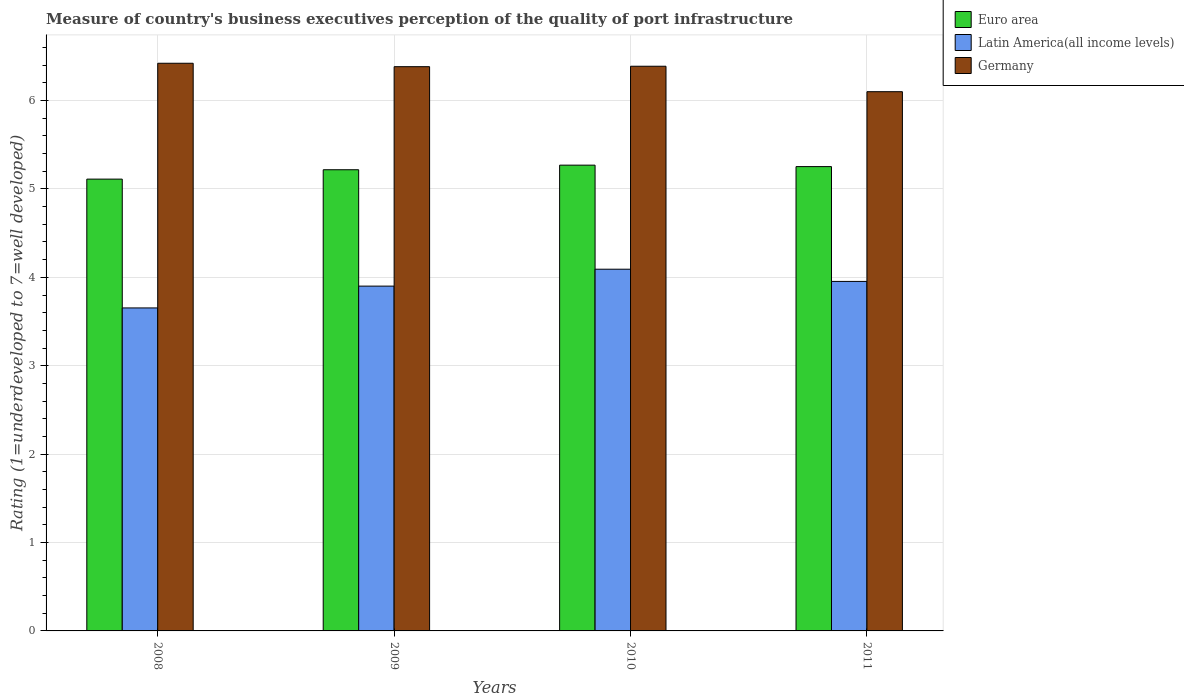How many groups of bars are there?
Offer a very short reply. 4. Are the number of bars per tick equal to the number of legend labels?
Make the answer very short. Yes. How many bars are there on the 2nd tick from the left?
Keep it short and to the point. 3. How many bars are there on the 3rd tick from the right?
Offer a terse response. 3. What is the label of the 1st group of bars from the left?
Your response must be concise. 2008. In how many cases, is the number of bars for a given year not equal to the number of legend labels?
Provide a succinct answer. 0. What is the ratings of the quality of port infrastructure in Euro area in 2009?
Offer a terse response. 5.22. Across all years, what is the maximum ratings of the quality of port infrastructure in Germany?
Offer a terse response. 6.42. In which year was the ratings of the quality of port infrastructure in Germany minimum?
Give a very brief answer. 2011. What is the total ratings of the quality of port infrastructure in Latin America(all income levels) in the graph?
Keep it short and to the point. 15.6. What is the difference between the ratings of the quality of port infrastructure in Germany in 2009 and that in 2011?
Keep it short and to the point. 0.28. What is the difference between the ratings of the quality of port infrastructure in Euro area in 2010 and the ratings of the quality of port infrastructure in Germany in 2009?
Give a very brief answer. -1.11. What is the average ratings of the quality of port infrastructure in Euro area per year?
Ensure brevity in your answer.  5.21. In the year 2011, what is the difference between the ratings of the quality of port infrastructure in Latin America(all income levels) and ratings of the quality of port infrastructure in Germany?
Your answer should be very brief. -2.15. What is the ratio of the ratings of the quality of port infrastructure in Germany in 2009 to that in 2011?
Keep it short and to the point. 1.05. Is the ratings of the quality of port infrastructure in Euro area in 2009 less than that in 2010?
Your answer should be very brief. Yes. Is the difference between the ratings of the quality of port infrastructure in Latin America(all income levels) in 2008 and 2011 greater than the difference between the ratings of the quality of port infrastructure in Germany in 2008 and 2011?
Provide a succinct answer. No. What is the difference between the highest and the second highest ratings of the quality of port infrastructure in Latin America(all income levels)?
Your answer should be very brief. 0.14. What is the difference between the highest and the lowest ratings of the quality of port infrastructure in Euro area?
Offer a terse response. 0.16. Is the sum of the ratings of the quality of port infrastructure in Euro area in 2009 and 2010 greater than the maximum ratings of the quality of port infrastructure in Latin America(all income levels) across all years?
Your answer should be compact. Yes. What does the 1st bar from the right in 2008 represents?
Ensure brevity in your answer.  Germany. Are all the bars in the graph horizontal?
Keep it short and to the point. No. What is the difference between two consecutive major ticks on the Y-axis?
Your answer should be compact. 1. Does the graph contain grids?
Keep it short and to the point. Yes. Where does the legend appear in the graph?
Offer a terse response. Top right. How many legend labels are there?
Ensure brevity in your answer.  3. What is the title of the graph?
Offer a very short reply. Measure of country's business executives perception of the quality of port infrastructure. Does "Indonesia" appear as one of the legend labels in the graph?
Provide a short and direct response. No. What is the label or title of the Y-axis?
Offer a very short reply. Rating (1=underdeveloped to 7=well developed). What is the Rating (1=underdeveloped to 7=well developed) of Euro area in 2008?
Give a very brief answer. 5.11. What is the Rating (1=underdeveloped to 7=well developed) in Latin America(all income levels) in 2008?
Provide a short and direct response. 3.65. What is the Rating (1=underdeveloped to 7=well developed) in Germany in 2008?
Offer a terse response. 6.42. What is the Rating (1=underdeveloped to 7=well developed) in Euro area in 2009?
Your answer should be very brief. 5.22. What is the Rating (1=underdeveloped to 7=well developed) in Latin America(all income levels) in 2009?
Make the answer very short. 3.9. What is the Rating (1=underdeveloped to 7=well developed) of Germany in 2009?
Your answer should be compact. 6.38. What is the Rating (1=underdeveloped to 7=well developed) in Euro area in 2010?
Make the answer very short. 5.27. What is the Rating (1=underdeveloped to 7=well developed) in Latin America(all income levels) in 2010?
Your answer should be very brief. 4.09. What is the Rating (1=underdeveloped to 7=well developed) in Germany in 2010?
Offer a very short reply. 6.39. What is the Rating (1=underdeveloped to 7=well developed) in Euro area in 2011?
Your answer should be very brief. 5.25. What is the Rating (1=underdeveloped to 7=well developed) in Latin America(all income levels) in 2011?
Make the answer very short. 3.95. What is the Rating (1=underdeveloped to 7=well developed) of Germany in 2011?
Give a very brief answer. 6.1. Across all years, what is the maximum Rating (1=underdeveloped to 7=well developed) of Euro area?
Keep it short and to the point. 5.27. Across all years, what is the maximum Rating (1=underdeveloped to 7=well developed) of Latin America(all income levels)?
Provide a succinct answer. 4.09. Across all years, what is the maximum Rating (1=underdeveloped to 7=well developed) of Germany?
Your answer should be very brief. 6.42. Across all years, what is the minimum Rating (1=underdeveloped to 7=well developed) of Euro area?
Provide a succinct answer. 5.11. Across all years, what is the minimum Rating (1=underdeveloped to 7=well developed) in Latin America(all income levels)?
Your response must be concise. 3.65. What is the total Rating (1=underdeveloped to 7=well developed) in Euro area in the graph?
Your response must be concise. 20.85. What is the total Rating (1=underdeveloped to 7=well developed) of Latin America(all income levels) in the graph?
Offer a very short reply. 15.6. What is the total Rating (1=underdeveloped to 7=well developed) of Germany in the graph?
Keep it short and to the point. 25.29. What is the difference between the Rating (1=underdeveloped to 7=well developed) in Euro area in 2008 and that in 2009?
Provide a short and direct response. -0.11. What is the difference between the Rating (1=underdeveloped to 7=well developed) in Latin America(all income levels) in 2008 and that in 2009?
Offer a terse response. -0.25. What is the difference between the Rating (1=underdeveloped to 7=well developed) of Germany in 2008 and that in 2009?
Offer a terse response. 0.04. What is the difference between the Rating (1=underdeveloped to 7=well developed) of Euro area in 2008 and that in 2010?
Provide a short and direct response. -0.16. What is the difference between the Rating (1=underdeveloped to 7=well developed) of Latin America(all income levels) in 2008 and that in 2010?
Offer a very short reply. -0.44. What is the difference between the Rating (1=underdeveloped to 7=well developed) of Germany in 2008 and that in 2010?
Keep it short and to the point. 0.03. What is the difference between the Rating (1=underdeveloped to 7=well developed) in Euro area in 2008 and that in 2011?
Provide a short and direct response. -0.14. What is the difference between the Rating (1=underdeveloped to 7=well developed) of Germany in 2008 and that in 2011?
Provide a succinct answer. 0.32. What is the difference between the Rating (1=underdeveloped to 7=well developed) of Euro area in 2009 and that in 2010?
Your answer should be compact. -0.05. What is the difference between the Rating (1=underdeveloped to 7=well developed) in Latin America(all income levels) in 2009 and that in 2010?
Offer a very short reply. -0.19. What is the difference between the Rating (1=underdeveloped to 7=well developed) in Germany in 2009 and that in 2010?
Give a very brief answer. -0. What is the difference between the Rating (1=underdeveloped to 7=well developed) of Euro area in 2009 and that in 2011?
Keep it short and to the point. -0.04. What is the difference between the Rating (1=underdeveloped to 7=well developed) in Latin America(all income levels) in 2009 and that in 2011?
Offer a terse response. -0.05. What is the difference between the Rating (1=underdeveloped to 7=well developed) of Germany in 2009 and that in 2011?
Offer a terse response. 0.28. What is the difference between the Rating (1=underdeveloped to 7=well developed) in Euro area in 2010 and that in 2011?
Your response must be concise. 0.02. What is the difference between the Rating (1=underdeveloped to 7=well developed) of Latin America(all income levels) in 2010 and that in 2011?
Offer a very short reply. 0.14. What is the difference between the Rating (1=underdeveloped to 7=well developed) of Germany in 2010 and that in 2011?
Your answer should be very brief. 0.29. What is the difference between the Rating (1=underdeveloped to 7=well developed) of Euro area in 2008 and the Rating (1=underdeveloped to 7=well developed) of Latin America(all income levels) in 2009?
Make the answer very short. 1.21. What is the difference between the Rating (1=underdeveloped to 7=well developed) of Euro area in 2008 and the Rating (1=underdeveloped to 7=well developed) of Germany in 2009?
Ensure brevity in your answer.  -1.27. What is the difference between the Rating (1=underdeveloped to 7=well developed) in Latin America(all income levels) in 2008 and the Rating (1=underdeveloped to 7=well developed) in Germany in 2009?
Give a very brief answer. -2.73. What is the difference between the Rating (1=underdeveloped to 7=well developed) in Euro area in 2008 and the Rating (1=underdeveloped to 7=well developed) in Latin America(all income levels) in 2010?
Ensure brevity in your answer.  1.02. What is the difference between the Rating (1=underdeveloped to 7=well developed) in Euro area in 2008 and the Rating (1=underdeveloped to 7=well developed) in Germany in 2010?
Keep it short and to the point. -1.28. What is the difference between the Rating (1=underdeveloped to 7=well developed) in Latin America(all income levels) in 2008 and the Rating (1=underdeveloped to 7=well developed) in Germany in 2010?
Your response must be concise. -2.73. What is the difference between the Rating (1=underdeveloped to 7=well developed) of Euro area in 2008 and the Rating (1=underdeveloped to 7=well developed) of Latin America(all income levels) in 2011?
Give a very brief answer. 1.16. What is the difference between the Rating (1=underdeveloped to 7=well developed) of Euro area in 2008 and the Rating (1=underdeveloped to 7=well developed) of Germany in 2011?
Provide a short and direct response. -0.99. What is the difference between the Rating (1=underdeveloped to 7=well developed) in Latin America(all income levels) in 2008 and the Rating (1=underdeveloped to 7=well developed) in Germany in 2011?
Your answer should be compact. -2.45. What is the difference between the Rating (1=underdeveloped to 7=well developed) of Euro area in 2009 and the Rating (1=underdeveloped to 7=well developed) of Latin America(all income levels) in 2010?
Your answer should be very brief. 1.13. What is the difference between the Rating (1=underdeveloped to 7=well developed) of Euro area in 2009 and the Rating (1=underdeveloped to 7=well developed) of Germany in 2010?
Make the answer very short. -1.17. What is the difference between the Rating (1=underdeveloped to 7=well developed) in Latin America(all income levels) in 2009 and the Rating (1=underdeveloped to 7=well developed) in Germany in 2010?
Offer a terse response. -2.49. What is the difference between the Rating (1=underdeveloped to 7=well developed) of Euro area in 2009 and the Rating (1=underdeveloped to 7=well developed) of Latin America(all income levels) in 2011?
Provide a short and direct response. 1.26. What is the difference between the Rating (1=underdeveloped to 7=well developed) of Euro area in 2009 and the Rating (1=underdeveloped to 7=well developed) of Germany in 2011?
Your response must be concise. -0.88. What is the difference between the Rating (1=underdeveloped to 7=well developed) in Latin America(all income levels) in 2009 and the Rating (1=underdeveloped to 7=well developed) in Germany in 2011?
Your response must be concise. -2.2. What is the difference between the Rating (1=underdeveloped to 7=well developed) of Euro area in 2010 and the Rating (1=underdeveloped to 7=well developed) of Latin America(all income levels) in 2011?
Provide a short and direct response. 1.32. What is the difference between the Rating (1=underdeveloped to 7=well developed) of Euro area in 2010 and the Rating (1=underdeveloped to 7=well developed) of Germany in 2011?
Offer a very short reply. -0.83. What is the difference between the Rating (1=underdeveloped to 7=well developed) of Latin America(all income levels) in 2010 and the Rating (1=underdeveloped to 7=well developed) of Germany in 2011?
Give a very brief answer. -2.01. What is the average Rating (1=underdeveloped to 7=well developed) in Euro area per year?
Offer a terse response. 5.21. What is the average Rating (1=underdeveloped to 7=well developed) of Germany per year?
Offer a terse response. 6.32. In the year 2008, what is the difference between the Rating (1=underdeveloped to 7=well developed) in Euro area and Rating (1=underdeveloped to 7=well developed) in Latin America(all income levels)?
Keep it short and to the point. 1.46. In the year 2008, what is the difference between the Rating (1=underdeveloped to 7=well developed) in Euro area and Rating (1=underdeveloped to 7=well developed) in Germany?
Your answer should be compact. -1.31. In the year 2008, what is the difference between the Rating (1=underdeveloped to 7=well developed) of Latin America(all income levels) and Rating (1=underdeveloped to 7=well developed) of Germany?
Offer a terse response. -2.77. In the year 2009, what is the difference between the Rating (1=underdeveloped to 7=well developed) of Euro area and Rating (1=underdeveloped to 7=well developed) of Latin America(all income levels)?
Keep it short and to the point. 1.32. In the year 2009, what is the difference between the Rating (1=underdeveloped to 7=well developed) of Euro area and Rating (1=underdeveloped to 7=well developed) of Germany?
Your answer should be very brief. -1.17. In the year 2009, what is the difference between the Rating (1=underdeveloped to 7=well developed) of Latin America(all income levels) and Rating (1=underdeveloped to 7=well developed) of Germany?
Provide a succinct answer. -2.48. In the year 2010, what is the difference between the Rating (1=underdeveloped to 7=well developed) in Euro area and Rating (1=underdeveloped to 7=well developed) in Latin America(all income levels)?
Ensure brevity in your answer.  1.18. In the year 2010, what is the difference between the Rating (1=underdeveloped to 7=well developed) of Euro area and Rating (1=underdeveloped to 7=well developed) of Germany?
Your answer should be very brief. -1.12. In the year 2010, what is the difference between the Rating (1=underdeveloped to 7=well developed) in Latin America(all income levels) and Rating (1=underdeveloped to 7=well developed) in Germany?
Your answer should be compact. -2.3. In the year 2011, what is the difference between the Rating (1=underdeveloped to 7=well developed) of Euro area and Rating (1=underdeveloped to 7=well developed) of Latin America(all income levels)?
Provide a short and direct response. 1.3. In the year 2011, what is the difference between the Rating (1=underdeveloped to 7=well developed) in Euro area and Rating (1=underdeveloped to 7=well developed) in Germany?
Provide a succinct answer. -0.85. In the year 2011, what is the difference between the Rating (1=underdeveloped to 7=well developed) in Latin America(all income levels) and Rating (1=underdeveloped to 7=well developed) in Germany?
Keep it short and to the point. -2.15. What is the ratio of the Rating (1=underdeveloped to 7=well developed) in Euro area in 2008 to that in 2009?
Your answer should be compact. 0.98. What is the ratio of the Rating (1=underdeveloped to 7=well developed) in Latin America(all income levels) in 2008 to that in 2009?
Offer a very short reply. 0.94. What is the ratio of the Rating (1=underdeveloped to 7=well developed) in Euro area in 2008 to that in 2010?
Ensure brevity in your answer.  0.97. What is the ratio of the Rating (1=underdeveloped to 7=well developed) of Latin America(all income levels) in 2008 to that in 2010?
Ensure brevity in your answer.  0.89. What is the ratio of the Rating (1=underdeveloped to 7=well developed) of Germany in 2008 to that in 2010?
Provide a short and direct response. 1.01. What is the ratio of the Rating (1=underdeveloped to 7=well developed) of Latin America(all income levels) in 2008 to that in 2011?
Make the answer very short. 0.92. What is the ratio of the Rating (1=underdeveloped to 7=well developed) of Germany in 2008 to that in 2011?
Give a very brief answer. 1.05. What is the ratio of the Rating (1=underdeveloped to 7=well developed) in Euro area in 2009 to that in 2010?
Your answer should be compact. 0.99. What is the ratio of the Rating (1=underdeveloped to 7=well developed) in Latin America(all income levels) in 2009 to that in 2010?
Make the answer very short. 0.95. What is the ratio of the Rating (1=underdeveloped to 7=well developed) in Euro area in 2009 to that in 2011?
Provide a succinct answer. 0.99. What is the ratio of the Rating (1=underdeveloped to 7=well developed) in Latin America(all income levels) in 2009 to that in 2011?
Your answer should be very brief. 0.99. What is the ratio of the Rating (1=underdeveloped to 7=well developed) of Germany in 2009 to that in 2011?
Your answer should be compact. 1.05. What is the ratio of the Rating (1=underdeveloped to 7=well developed) in Latin America(all income levels) in 2010 to that in 2011?
Ensure brevity in your answer.  1.03. What is the ratio of the Rating (1=underdeveloped to 7=well developed) of Germany in 2010 to that in 2011?
Your response must be concise. 1.05. What is the difference between the highest and the second highest Rating (1=underdeveloped to 7=well developed) of Euro area?
Ensure brevity in your answer.  0.02. What is the difference between the highest and the second highest Rating (1=underdeveloped to 7=well developed) of Latin America(all income levels)?
Keep it short and to the point. 0.14. What is the difference between the highest and the second highest Rating (1=underdeveloped to 7=well developed) in Germany?
Your response must be concise. 0.03. What is the difference between the highest and the lowest Rating (1=underdeveloped to 7=well developed) in Euro area?
Your answer should be compact. 0.16. What is the difference between the highest and the lowest Rating (1=underdeveloped to 7=well developed) of Latin America(all income levels)?
Your response must be concise. 0.44. What is the difference between the highest and the lowest Rating (1=underdeveloped to 7=well developed) in Germany?
Your response must be concise. 0.32. 